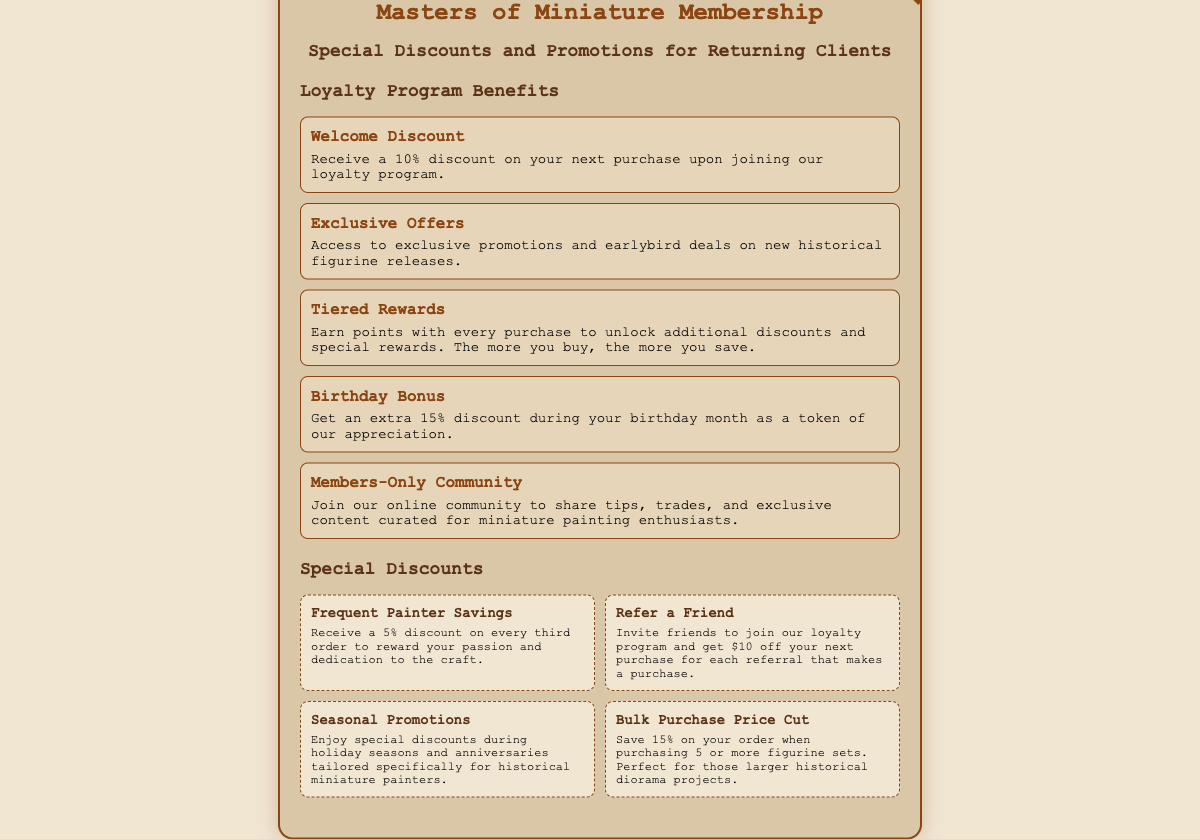What is the welcome discount percentage? The welcome discount for joining the loyalty program is stated as 10%.
Answer: 10% What is the birthday bonus discount? The document mentions an extra discount during your birthday month of 15%.
Answer: 15% How much do you save on every third order? The text specifies that you receive a 5% discount on every third order.
Answer: 5% What do you receive for referring a friend? The document states that you get $10 off your next purchase for each successful referral.
Answer: $10 What is the discount for bulk purchases of 5 or more figurine sets? The information includes a 15% discount for purchasing 5 or more figurine sets.
Answer: 15% What is the name of the loyalty program mentioned? The document refers to the program as "Masters of Miniature Membership."
Answer: Masters of Miniature Membership What type of community can members join? The card mentions that members can join an online community specifically for miniature painting enthusiasts.
Answer: Members-Only Community What type of discounts are available during holiday seasons? The text includes "Seasonal Promotions" as special discounts during holiday seasons.
Answer: Seasonal Promotions How many points do you earn with every purchase? The document details a tiered rewards system but does not specify the number of points per purchase.
Answer: Not specified 